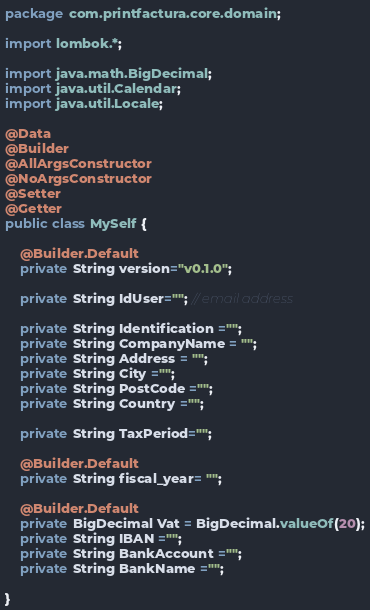<code> <loc_0><loc_0><loc_500><loc_500><_Java_>package com.printfactura.core.domain;

import lombok.*;

import java.math.BigDecimal;
import java.util.Calendar;
import java.util.Locale;

@Data
@Builder
@AllArgsConstructor
@NoArgsConstructor
@Setter
@Getter
public class MySelf {

    @Builder.Default
    private String version="v0.1.0";

    private String IdUser=""; // email address

    private String Identification ="";
    private String CompanyName = "";
    private String Address = "";
    private String City ="";
    private String PostCode ="";
    private String Country ="";

    private String TaxPeriod="";

    @Builder.Default
    private String fiscal_year= "";

    @Builder.Default
    private BigDecimal Vat = BigDecimal.valueOf(20);
    private String IBAN ="";
    private String BankAccount ="";
    private String BankName ="";

}
</code> 